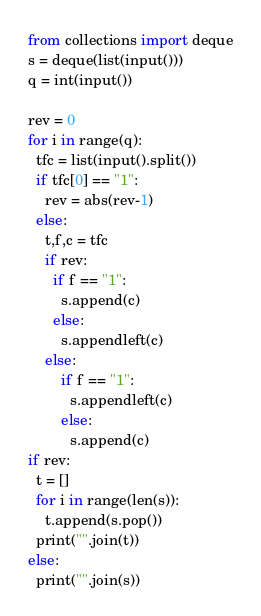Convert code to text. <code><loc_0><loc_0><loc_500><loc_500><_Python_>from collections import deque
s = deque(list(input()))
q = int(input())

rev = 0
for i in range(q):
  tfc = list(input().split())
  if tfc[0] == "1":
    rev = abs(rev-1)
  else:
    t,f,c = tfc
    if rev:
      if f == "1":
        s.append(c)
      else:
        s.appendleft(c)
    else:
        if f == "1":
          s.appendleft(c)
        else:
          s.append(c)
if rev:
  t = []
  for i in range(len(s)):
    t.append(s.pop())
  print("".join(t))
else:
  print("".join(s))</code> 